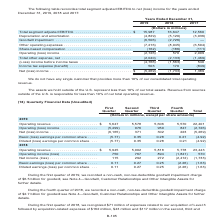According to Centurylink's financial document, What is the Depreciation and amortization for 2019? According to the financial document, (4,829) (in millions). The relevant text states: ",987 16,647 12,560 Depreciation and amortization . (4,829) (5,120) (3,936) Goodwill impairment . (6,506) (2,726) — Other operating expenses . (7,216) (8,045) (..." Also, What is the total segment adjusted EBITDA in 2019? According to the financial document, $15,987 (in millions). The relevant text states: "rs in millions) Total segment adjusted EBITDA . $ 15,987 16,647 12,560 Depreciation and amortization . (4,829) (5,120) (3,936) Goodwill impairment . (6,506)..." Also, What years does the table reconcile total segment adjusted EBITDA to net (loss) income for? The document contains multiple relevant values: 2019, 2018, 2017. From the document: "2019 2018 2017 2019 2018 2017 2019 2018 2017..." Additionally, Which year has the largest total segment adjusted EBITDA? According to the financial document, 2018. The relevant text states: "2019 2018 2017..." Also, can you calculate: What is the sum of income tax expense (benefit) in 2018 and 2019? Based on the calculation: 503+170, the result is 673 (in millions). This is based on the information: "6) (1,563) 540 Income tax expense (benefit) . 503 170 (849) 4,766) (1,563) 540 Income tax expense (benefit) . 503 170 (849)..." The key data points involved are: 170, 503. Also, can you calculate: What is the percentage change in income tax expense (benefit) in 2019 from 2018? To answer this question, I need to perform calculations using the financial data. The calculation is: (503-170)/170, which equals 195.88 (percentage). This is based on the information: "6) (1,563) 540 Income tax expense (benefit) . 503 170 (849) 4,766) (1,563) 540 Income tax expense (benefit) . 503 170 (849)..." The key data points involved are: 170, 503. 